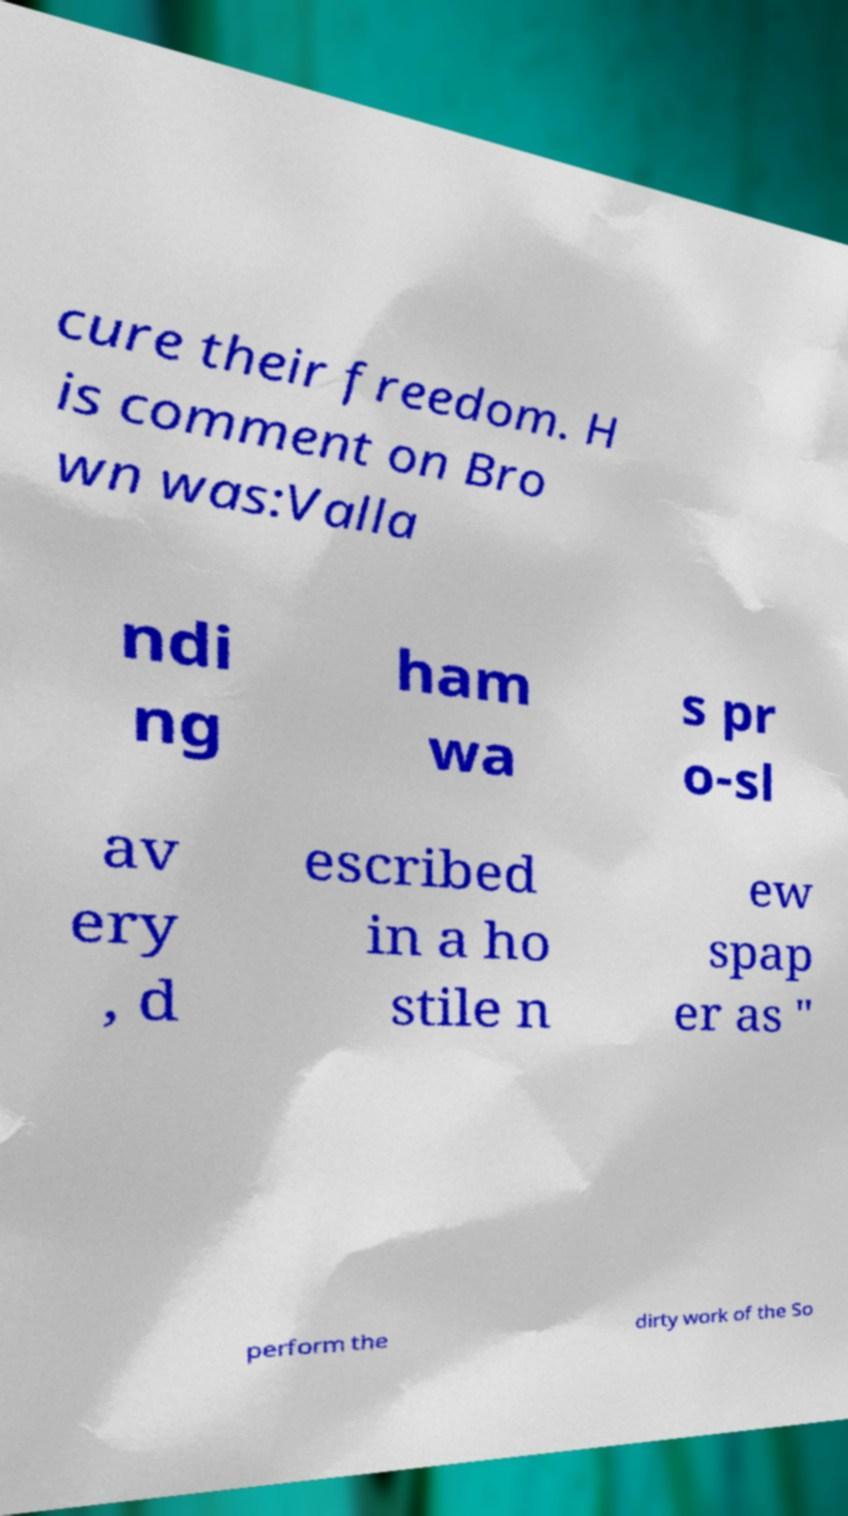I need the written content from this picture converted into text. Can you do that? cure their freedom. H is comment on Bro wn was:Valla ndi ng ham wa s pr o-sl av ery , d escribed in a ho stile n ew spap er as " perform the dirty work of the So 